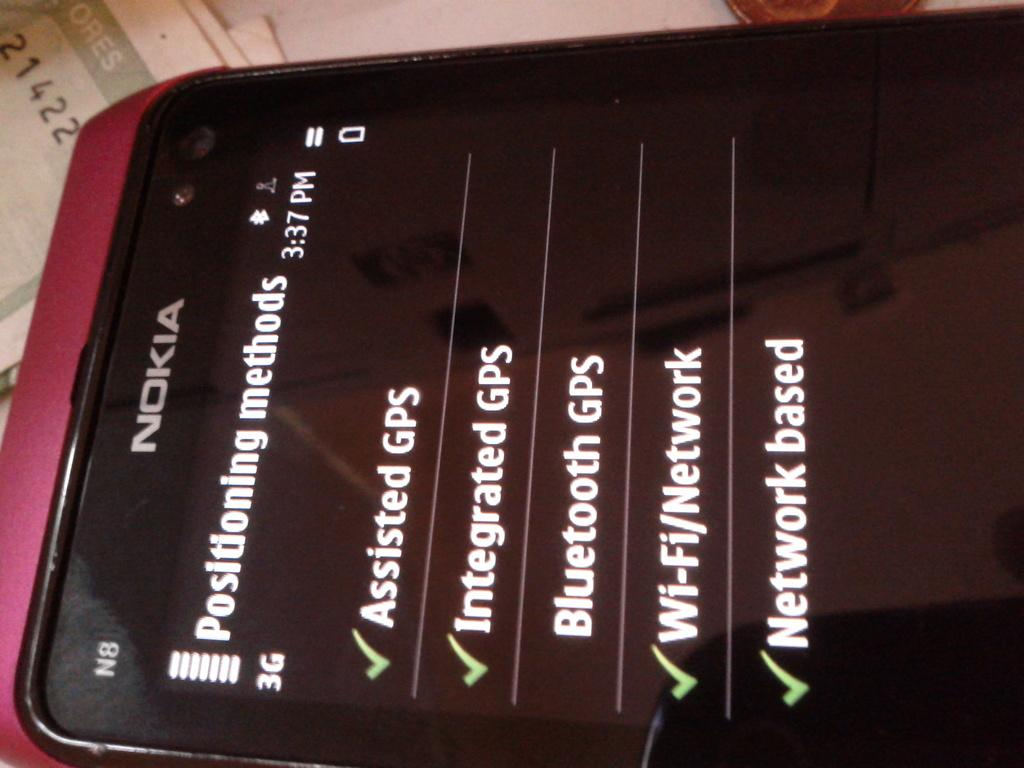<image>
Give a short and clear explanation of the subsequent image. A Nokia cellphone with its GPS positioning methods option screen displayed 